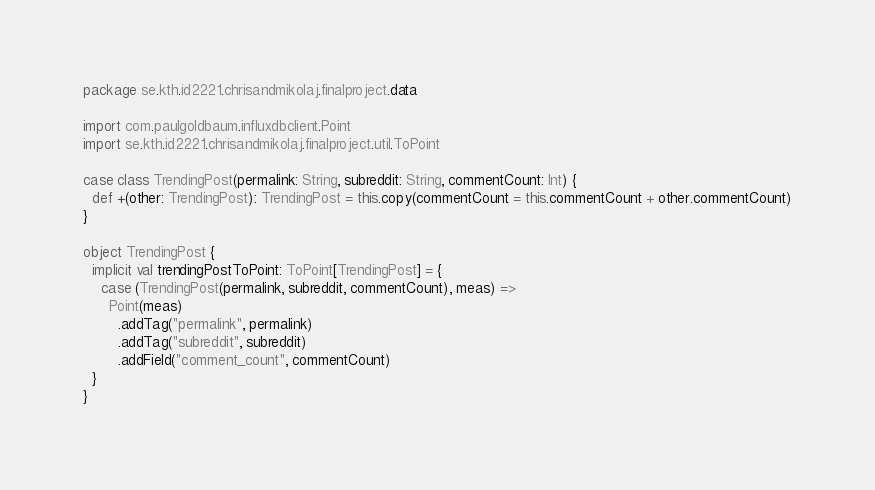Convert code to text. <code><loc_0><loc_0><loc_500><loc_500><_Scala_>package se.kth.id2221.chrisandmikolaj.finalproject.data

import com.paulgoldbaum.influxdbclient.Point
import se.kth.id2221.chrisandmikolaj.finalproject.util.ToPoint

case class TrendingPost(permalink: String, subreddit: String, commentCount: Int) {
  def +(other: TrendingPost): TrendingPost = this.copy(commentCount = this.commentCount + other.commentCount)
}

object TrendingPost {
  implicit val trendingPostToPoint: ToPoint[TrendingPost] = {
    case (TrendingPost(permalink, subreddit, commentCount), meas) =>
      Point(meas)
        .addTag("permalink", permalink)
        .addTag("subreddit", subreddit)
        .addField("comment_count", commentCount)
  }
}
</code> 